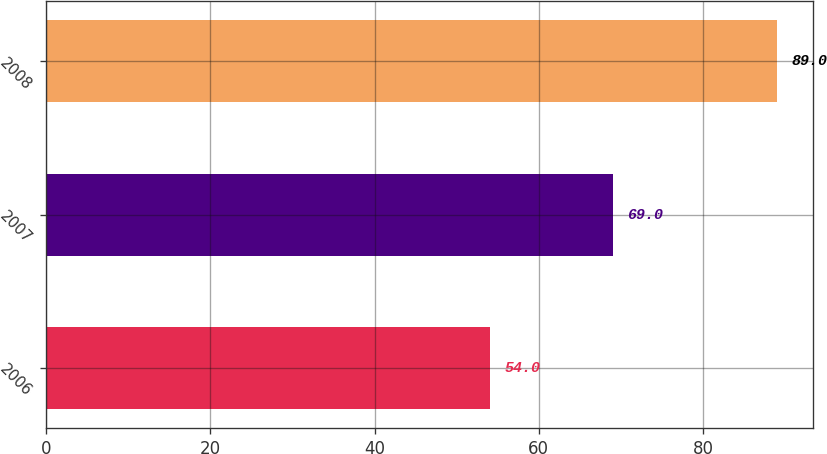<chart> <loc_0><loc_0><loc_500><loc_500><bar_chart><fcel>2006<fcel>2007<fcel>2008<nl><fcel>54<fcel>69<fcel>89<nl></chart> 